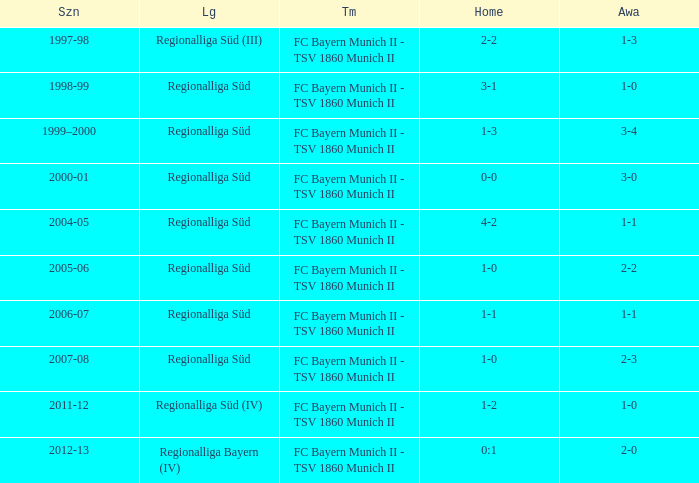Which teams were in the 2006-07 season? FC Bayern Munich II - TSV 1860 Munich II. Could you parse the entire table? {'header': ['Szn', 'Lg', 'Tm', 'Home', 'Awa'], 'rows': [['1997-98', 'Regionalliga Süd (III)', 'FC Bayern Munich II - TSV 1860 Munich II', '2-2', '1-3'], ['1998-99', 'Regionalliga Süd', 'FC Bayern Munich II - TSV 1860 Munich II', '3-1', '1-0'], ['1999–2000', 'Regionalliga Süd', 'FC Bayern Munich II - TSV 1860 Munich II', '1-3', '3-4'], ['2000-01', 'Regionalliga Süd', 'FC Bayern Munich II - TSV 1860 Munich II', '0-0', '3-0'], ['2004-05', 'Regionalliga Süd', 'FC Bayern Munich II - TSV 1860 Munich II', '4-2', '1-1'], ['2005-06', 'Regionalliga Süd', 'FC Bayern Munich II - TSV 1860 Munich II', '1-0', '2-2'], ['2006-07', 'Regionalliga Süd', 'FC Bayern Munich II - TSV 1860 Munich II', '1-1', '1-1'], ['2007-08', 'Regionalliga Süd', 'FC Bayern Munich II - TSV 1860 Munich II', '1-0', '2-3'], ['2011-12', 'Regionalliga Süd (IV)', 'FC Bayern Munich II - TSV 1860 Munich II', '1-2', '1-0'], ['2012-13', 'Regionalliga Bayern (IV)', 'FC Bayern Munich II - TSV 1860 Munich II', '0:1', '2-0']]} 